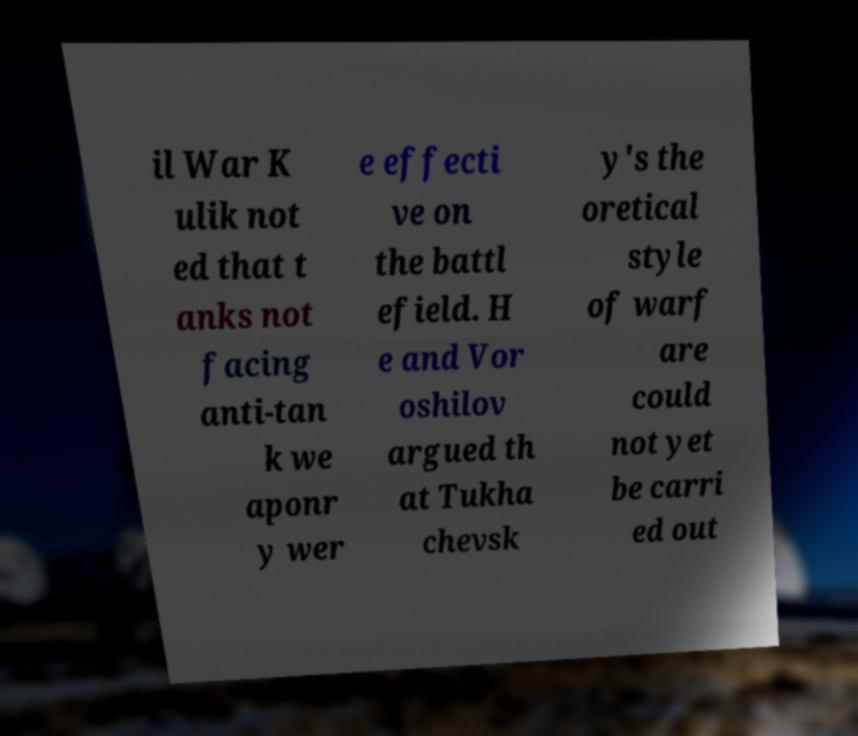Could you assist in decoding the text presented in this image and type it out clearly? il War K ulik not ed that t anks not facing anti-tan k we aponr y wer e effecti ve on the battl efield. H e and Vor oshilov argued th at Tukha chevsk y's the oretical style of warf are could not yet be carri ed out 